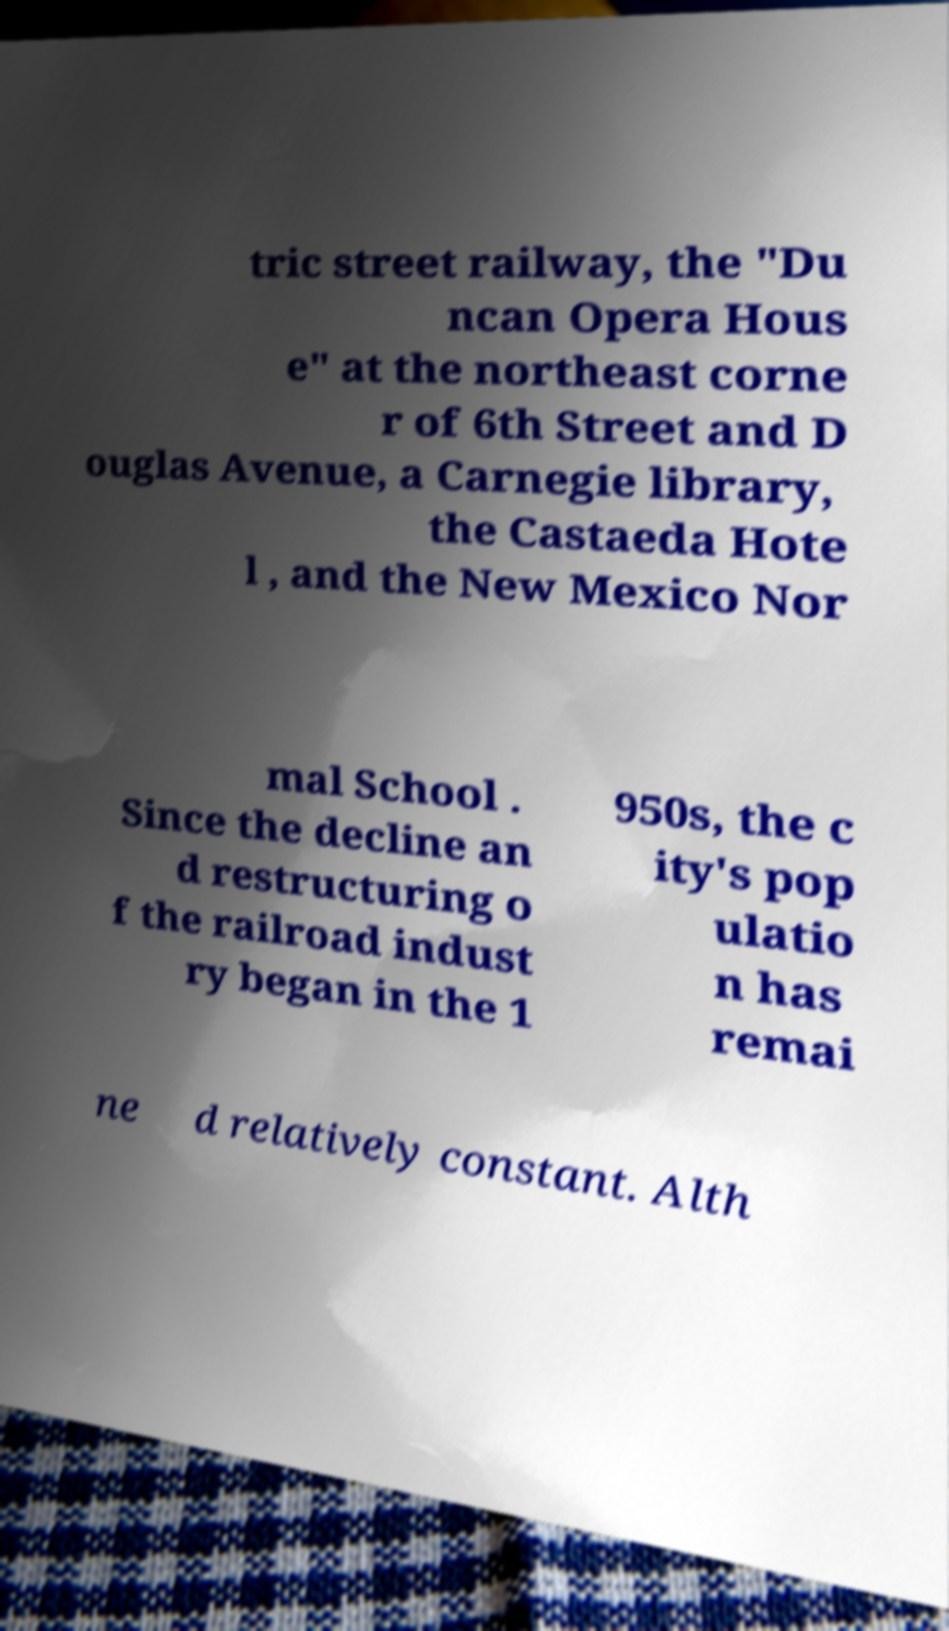For documentation purposes, I need the text within this image transcribed. Could you provide that? tric street railway, the "Du ncan Opera Hous e" at the northeast corne r of 6th Street and D ouglas Avenue, a Carnegie library, the Castaeda Hote l , and the New Mexico Nor mal School . Since the decline an d restructuring o f the railroad indust ry began in the 1 950s, the c ity's pop ulatio n has remai ne d relatively constant. Alth 